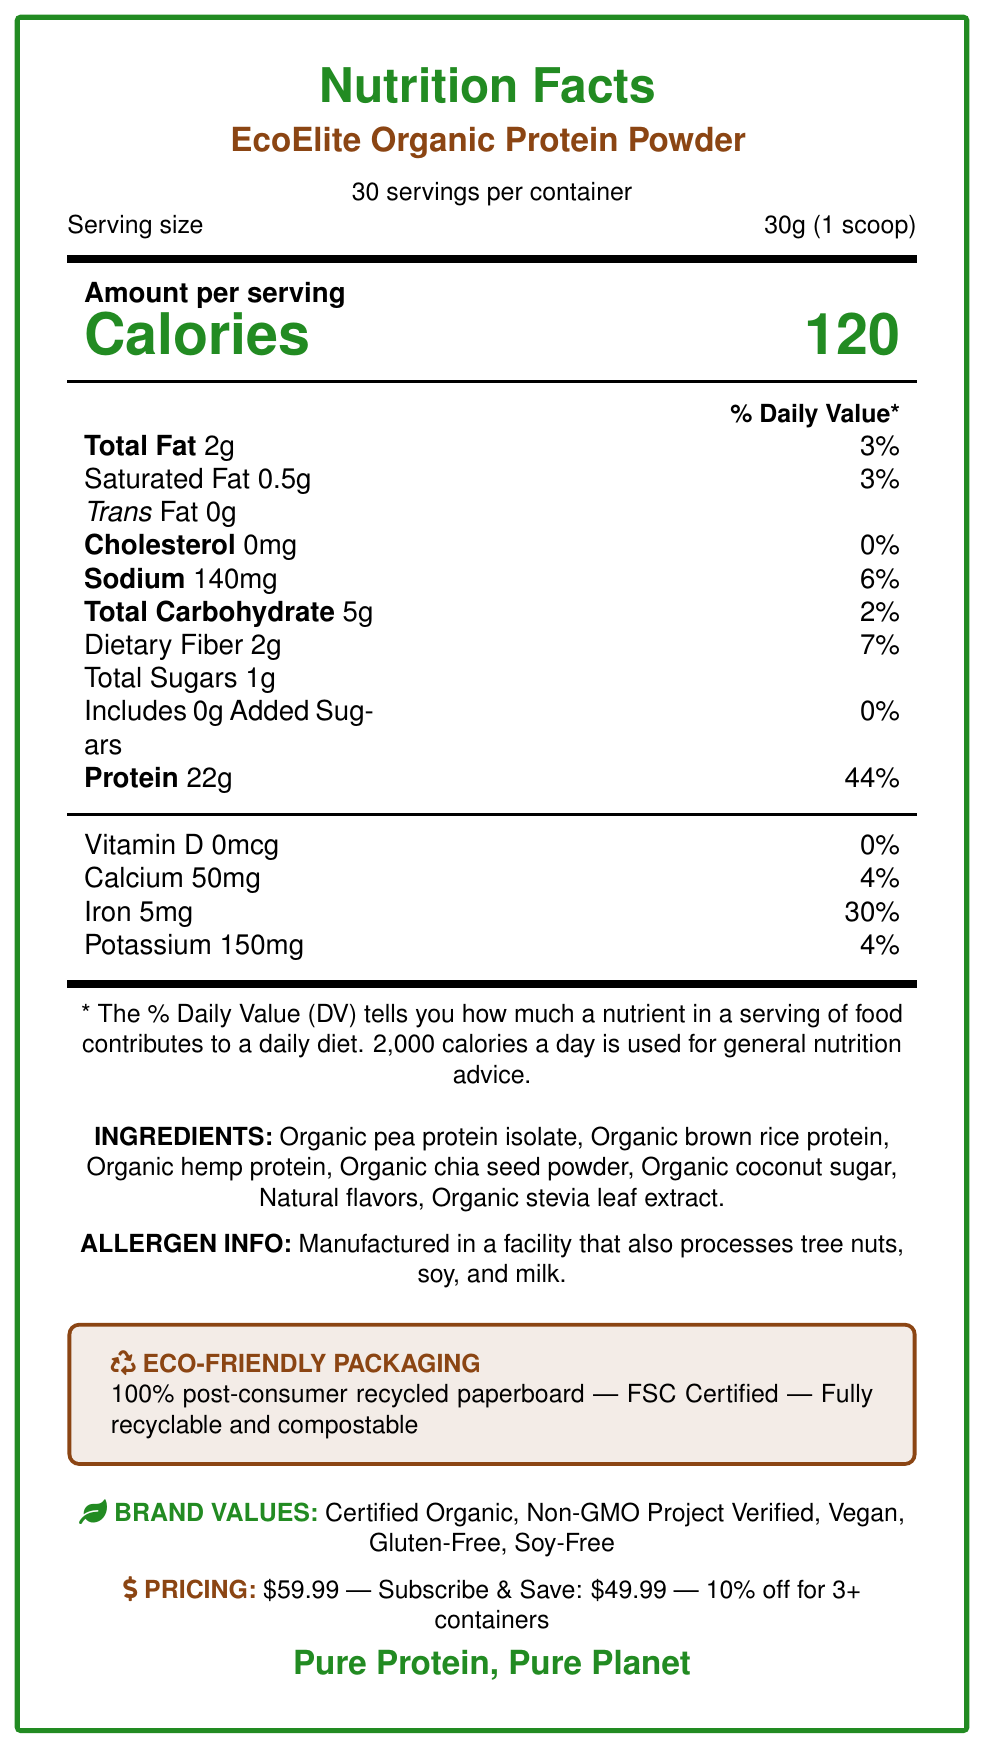How many servings per container does the EcoElite Organic Protein Powder have? The document states that there are 30 servings per container.
Answer: 30 What is the serving size for the EcoElite Organic Protein Powder? According to the document, each serving size is 30 grams, which is equivalent to one scoop.
Answer: 30g (1 scoop) What is the total fat content per serving of the EcoElite Organic Protein Powder? The Nutrition Facts label specifies that the total fat content per serving is 2 grams.
Answer: 2g How many grams of protein are in one serving of this product? The document indicates that each serving contains 22 grams of protein.
Answer: 22g What are the ingredients listed for the EcoElite Organic Protein Powder? The section titled "INGREDIENTS" lists all the ingredients in the product.
Answer: Organic pea protein isolate, Organic brown rice protein, Organic hemp protein, Organic chia seed powder, Organic coconut sugar, Natural flavors, Organic stevia leaf extract. What percentage of the daily value for iron does one serving provide? A. 4% B. 7% C. 30% D. 44% The document states that one serving provides 30% of the daily value for iron.
Answer: C. 30% Which of the following allergens are processed in the same facility as the EcoElite Organic Protein Powder? A. Peanuts, soy, and wheat B. Tree nuts, soy, and milk C. Shellfish, tree nuts, and soy D. Milk, peanuts, and shellfish The allergen information states that the product is manufactured in a facility that processes tree nuts, soy, and milk.
Answer: B. Tree nuts, soy, and milk Is the packaging of the EcoElite Organic Protein Powder recyclable and compostable? The eco-friendly packaging section states that the packaging is fully recyclable and compostable.
Answer: Yes What is the tagline of the EcoElite Organic Protein Powder? The tagline is mentioned at the bottom of the document in a larger font.
Answer: Pure Protein, Pure Planet Describe the main idea of the document. The document presents comprehensive information about the nutritional content, ingredients, allergen information, and eco-friendly packaging of the product. It also highlights the brand values, pricing strategy, and branding elements, making it clear that this is a premium, eco-conscious product.
Answer: The document provides detailed nutritional information, ingredients, allergen information, eco-friendly packaging details, brand values, pricing strategy, and branding elements for the EcoElite Organic Protein Powder. What is the retail price of the EcoElite Organic Protein Powder? The pricing section states that the retail price is $59.99.
Answer: $59.99 How much sodium is in one serving of the EcoElite Organic Protein Powder? The Nutrition Facts label shows that each serving contains 140 mg of sodium.
Answer: 140mg Can the document tell us whether the product is effective for muscle growth? The document provides nutritional information but does not contain any information or claims regarding the product's effectiveness for muscle growth.
Answer: Cannot be determined What daily value percentage does the total carbohydrate content represent? According to the Nutrition Facts label, the total carbohydrate content of 5 grams represents 2% of the daily value.
Answer: 2% Can this product be considered vegan? The brand values section lists "Vegan" as one of the certifications, indicating that the product is suitable for vegans.
Answer: Yes Which colors are part of the EcoElite Organic Protein Powder's branding color scheme? The branding elements section specifies these three colors as part of the color scheme.
Answer: Forest Green, Earth Brown, Clean White What is the eco-friendly packaging material made from? The document indicates that the packaging is made from 100% post-consumer recycled paperboard.
Answer: 100% post-consumer recycled paperboard 